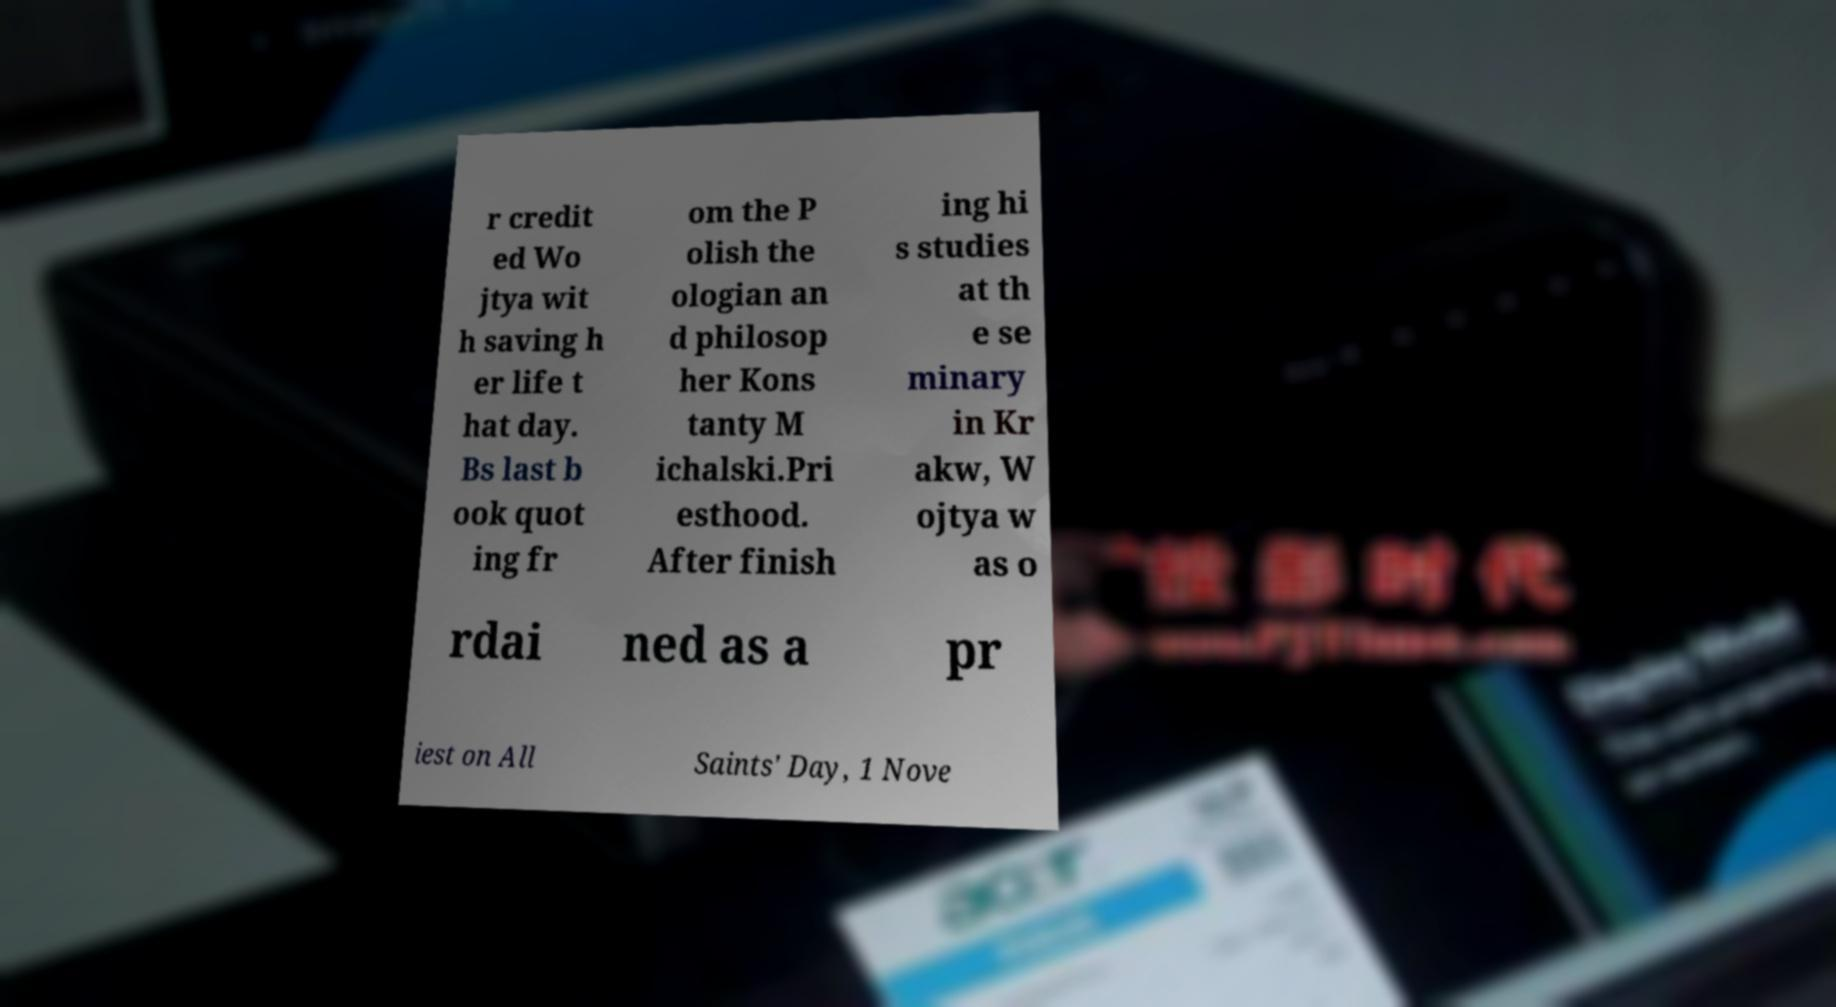Could you assist in decoding the text presented in this image and type it out clearly? r credit ed Wo jtya wit h saving h er life t hat day. Bs last b ook quot ing fr om the P olish the ologian an d philosop her Kons tanty M ichalski.Pri esthood. After finish ing hi s studies at th e se minary in Kr akw, W ojtya w as o rdai ned as a pr iest on All Saints' Day, 1 Nove 